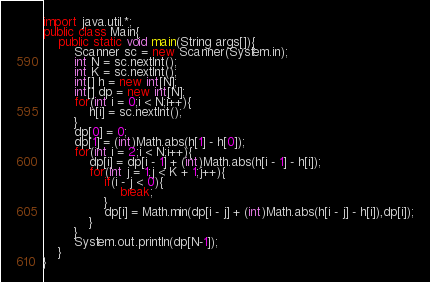<code> <loc_0><loc_0><loc_500><loc_500><_Java_>import java.util.*;
public class Main{
	public static void main(String args[]){
		Scanner sc = new Scanner(System.in);
		int N = sc.nextInt();
		int K = sc.nextInt();
		int[] h = new int[N];
		int[] dp = new int[N];
		for(int i = 0;i < N;i++){
			h[i] = sc.nextInt();
		}
		dp[0] = 0;
		dp[1] = (int)Math.abs(h[1] - h[0]);
		for(int i = 2;i < N;i++){
			dp[i] = dp[i - 1] + (int)Math.abs(h[i - 1] - h[i]);
			for(int j = 1;j < K + 1;j++){
				if(i - j < 0){
					break;
				}
				dp[i] = Math.min(dp[i - j] + (int)Math.abs(h[i - j] - h[i]),dp[i]);
			}
		}
		System.out.println(dp[N-1]);
	}
}</code> 